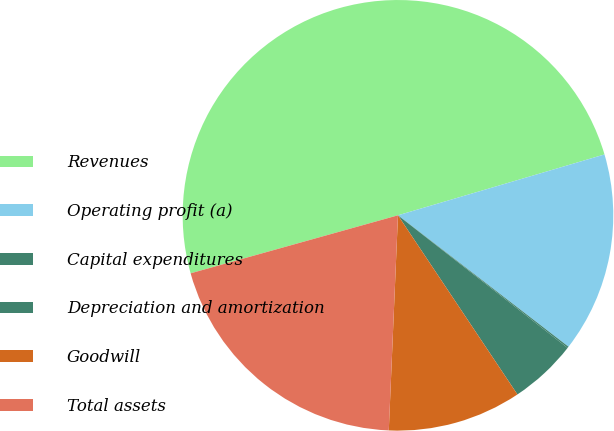<chart> <loc_0><loc_0><loc_500><loc_500><pie_chart><fcel>Revenues<fcel>Operating profit (a)<fcel>Capital expenditures<fcel>Depreciation and amortization<fcel>Goodwill<fcel>Total assets<nl><fcel>49.78%<fcel>15.01%<fcel>0.11%<fcel>5.08%<fcel>10.04%<fcel>19.98%<nl></chart> 